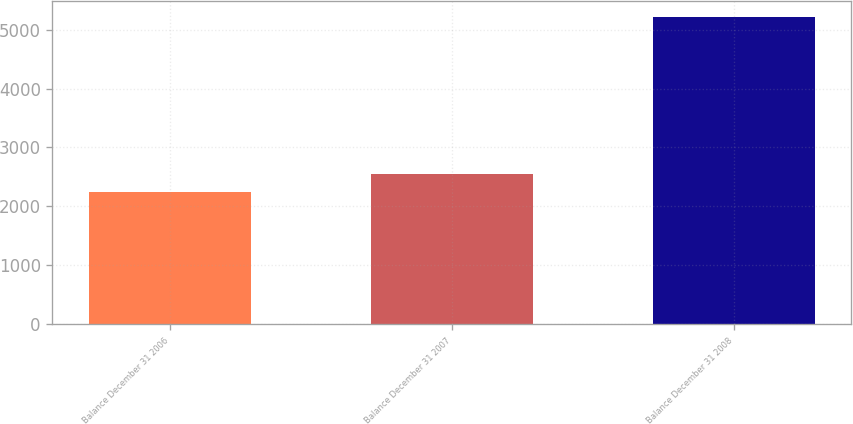Convert chart to OTSL. <chart><loc_0><loc_0><loc_500><loc_500><bar_chart><fcel>Balance December 31 2006<fcel>Balance December 31 2007<fcel>Balance December 31 2008<nl><fcel>2244.7<fcel>2542.73<fcel>5225<nl></chart> 